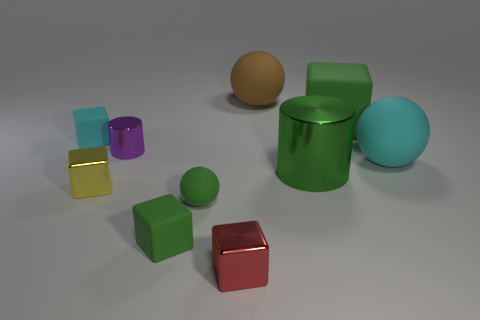There is a rubber cube in front of the green rubber sphere; is it the same size as the cyan matte object right of the tiny yellow metallic object? The green rubber sphere has a prominent presence in the image with its vibrant color and smooth texture. Upon closer inspection, it becomes evident that the rubber cube in front of the green sphere is not the same size as the cyan matte object. The cyan object has larger dimensions compared to the cube, and this disparity in scale helps to create an intriguing composition within the image. 